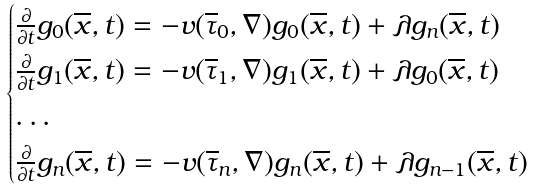Convert formula to latex. <formula><loc_0><loc_0><loc_500><loc_500>\begin{cases} \frac { \partial } { \partial t } g _ { 0 } ( \overline { x } , t ) = - v ( \overline { \tau } _ { 0 } , \nabla ) g _ { 0 } ( \overline { x } , t ) + \lambda g _ { n } ( \overline { x } , t ) \\ \frac { \partial } { \partial t } g _ { 1 } ( \overline { x } , t ) = - v ( \overline { \tau } _ { 1 } , \nabla ) g _ { 1 } ( \overline { x } , t ) + \lambda g _ { 0 } ( \overline { x } , t ) \\ \dots \\ \frac { \partial } { \partial t } g _ { n } ( \overline { x } , t ) = - v ( \overline { \tau } _ { n } , \nabla ) g _ { n } ( \overline { x } , t ) + \lambda g _ { n - 1 } ( \overline { x } , t ) \end{cases}</formula> 